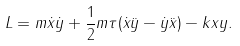Convert formula to latex. <formula><loc_0><loc_0><loc_500><loc_500>L = m \dot { x } \dot { y } + \frac { 1 } { 2 } m \tau ( \dot { x } \ddot { y } - \dot { y } \ddot { x } ) - k x y .</formula> 